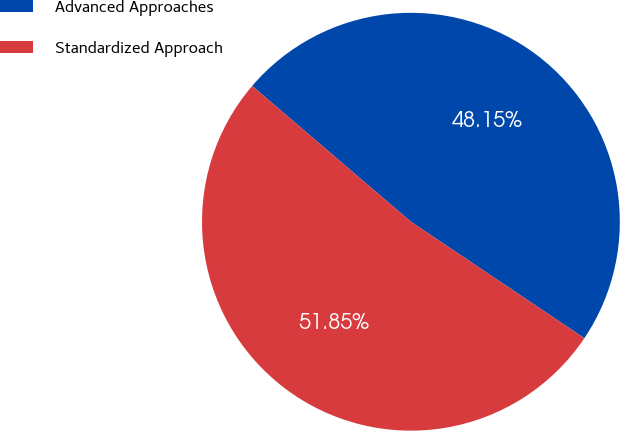Convert chart. <chart><loc_0><loc_0><loc_500><loc_500><pie_chart><fcel>Advanced Approaches<fcel>Standardized Approach<nl><fcel>48.15%<fcel>51.85%<nl></chart> 